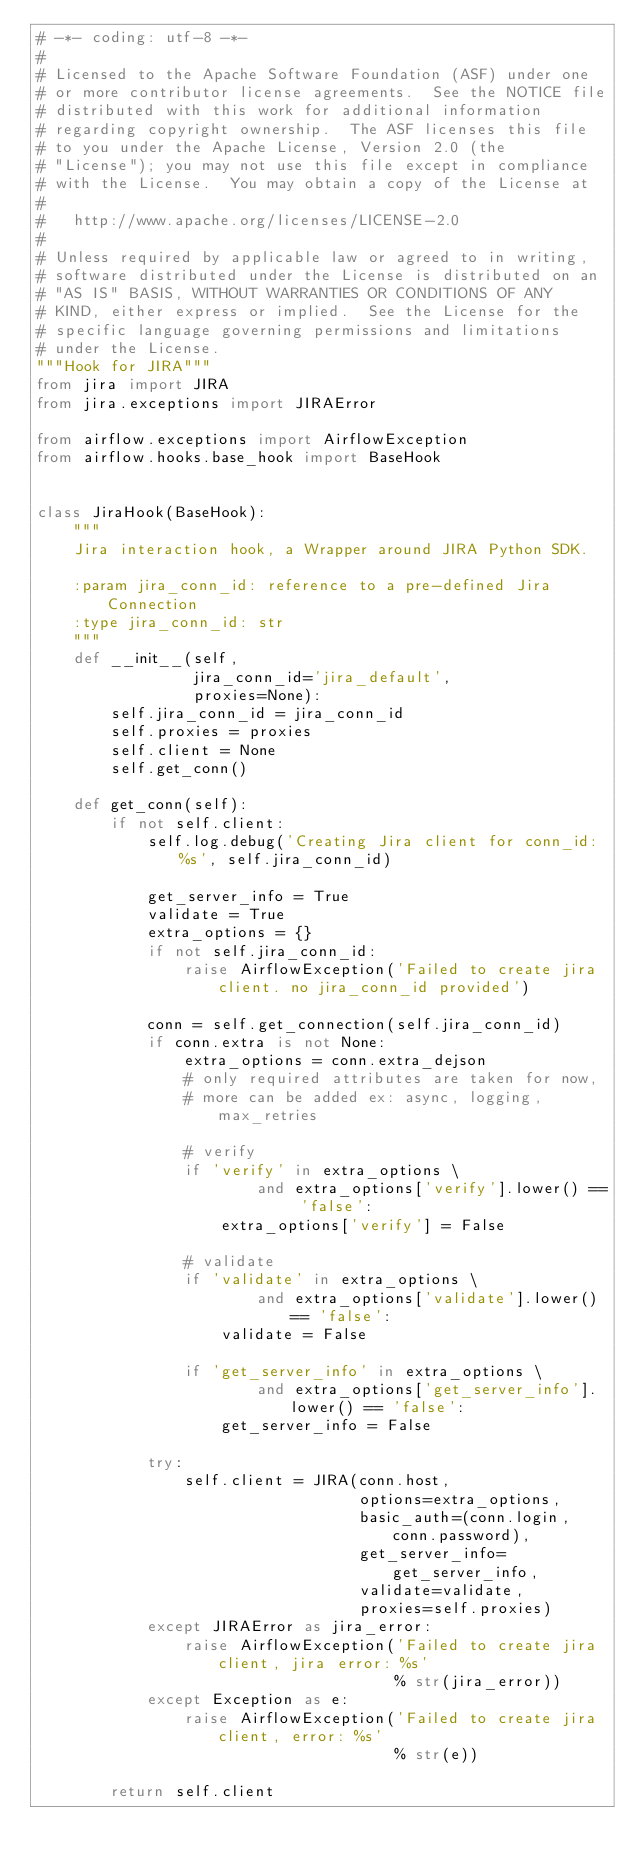<code> <loc_0><loc_0><loc_500><loc_500><_Python_># -*- coding: utf-8 -*-
#
# Licensed to the Apache Software Foundation (ASF) under one
# or more contributor license agreements.  See the NOTICE file
# distributed with this work for additional information
# regarding copyright ownership.  The ASF licenses this file
# to you under the Apache License, Version 2.0 (the
# "License"); you may not use this file except in compliance
# with the License.  You may obtain a copy of the License at
#
#   http://www.apache.org/licenses/LICENSE-2.0
#
# Unless required by applicable law or agreed to in writing,
# software distributed under the License is distributed on an
# "AS IS" BASIS, WITHOUT WARRANTIES OR CONDITIONS OF ANY
# KIND, either express or implied.  See the License for the
# specific language governing permissions and limitations
# under the License.
"""Hook for JIRA"""
from jira import JIRA
from jira.exceptions import JIRAError

from airflow.exceptions import AirflowException
from airflow.hooks.base_hook import BaseHook


class JiraHook(BaseHook):
    """
    Jira interaction hook, a Wrapper around JIRA Python SDK.

    :param jira_conn_id: reference to a pre-defined Jira Connection
    :type jira_conn_id: str
    """
    def __init__(self,
                 jira_conn_id='jira_default',
                 proxies=None):
        self.jira_conn_id = jira_conn_id
        self.proxies = proxies
        self.client = None
        self.get_conn()

    def get_conn(self):
        if not self.client:
            self.log.debug('Creating Jira client for conn_id: %s', self.jira_conn_id)

            get_server_info = True
            validate = True
            extra_options = {}
            if not self.jira_conn_id:
                raise AirflowException('Failed to create jira client. no jira_conn_id provided')

            conn = self.get_connection(self.jira_conn_id)
            if conn.extra is not None:
                extra_options = conn.extra_dejson
                # only required attributes are taken for now,
                # more can be added ex: async, logging, max_retries

                # verify
                if 'verify' in extra_options \
                        and extra_options['verify'].lower() == 'false':
                    extra_options['verify'] = False

                # validate
                if 'validate' in extra_options \
                        and extra_options['validate'].lower() == 'false':
                    validate = False

                if 'get_server_info' in extra_options \
                        and extra_options['get_server_info'].lower() == 'false':
                    get_server_info = False

            try:
                self.client = JIRA(conn.host,
                                   options=extra_options,
                                   basic_auth=(conn.login, conn.password),
                                   get_server_info=get_server_info,
                                   validate=validate,
                                   proxies=self.proxies)
            except JIRAError as jira_error:
                raise AirflowException('Failed to create jira client, jira error: %s'
                                       % str(jira_error))
            except Exception as e:
                raise AirflowException('Failed to create jira client, error: %s'
                                       % str(e))

        return self.client
</code> 